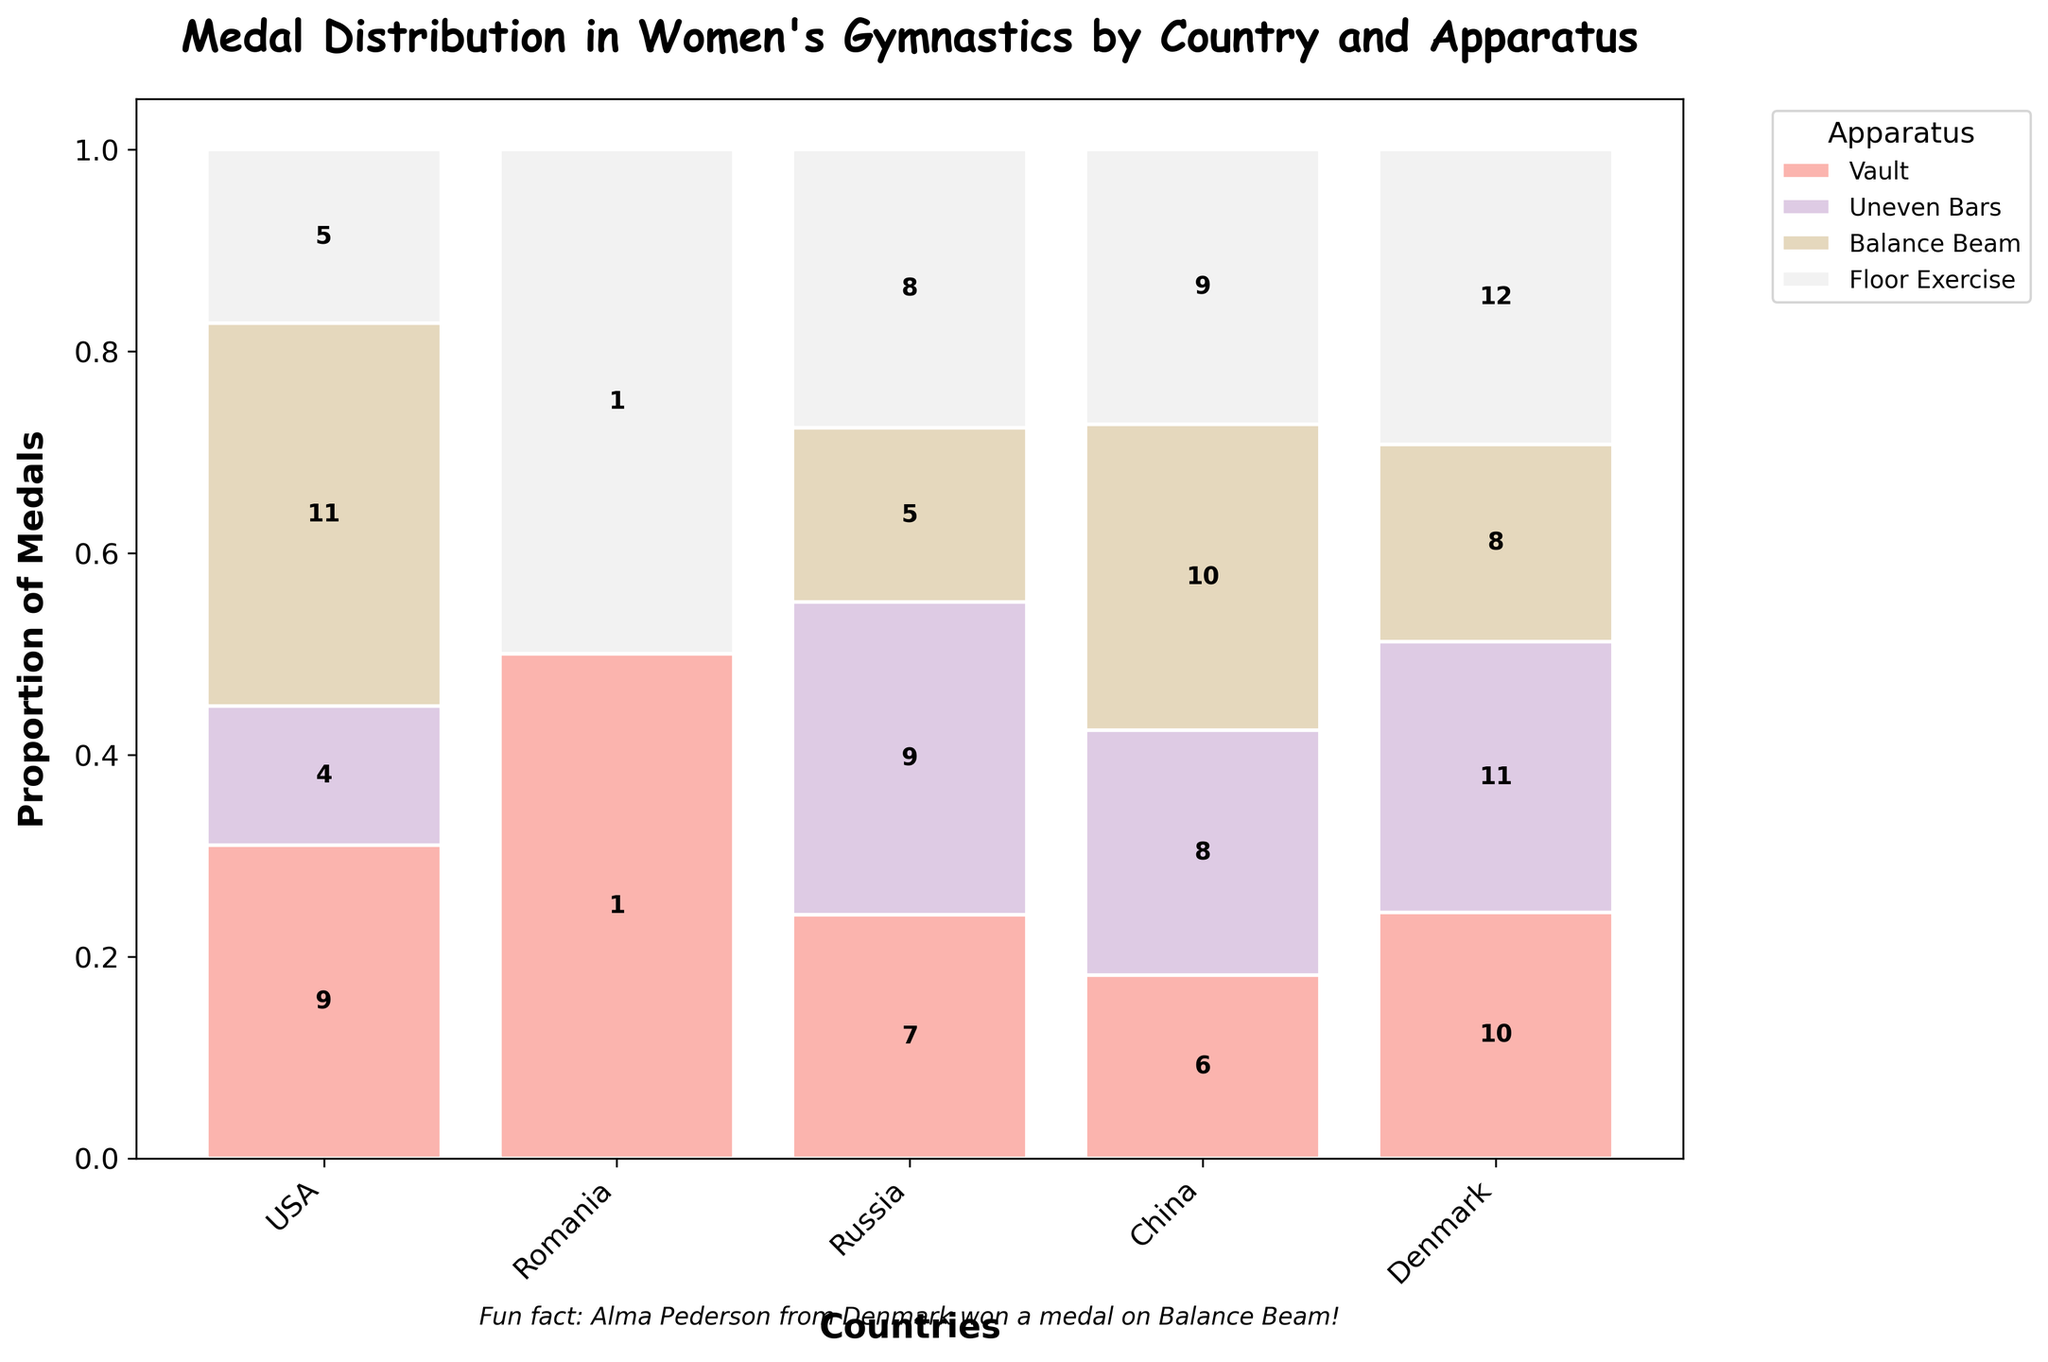What is the title of the plot? The title is displayed prominently above the plot in large, bold font. It reads "Medal Distribution in Women's Gymnastics by Country and Apparatus".
Answer: Medal Distribution in Women's Gymnastics by Country and Apparatus Which country has the highest proportional distribution in Vault? By observing the tallest segment colored for Vault, the USA has the highest segment.
Answer: USA How many medals did China win in the Uneven Bars? Each bar segment includes a label with the number of medals. The segment for China in Uneven Bars shows the number 11.
Answer: 11 What is the relative proportion of medals that Denmark received for Balance Beam? The segment for Denmark in Balance Beam should be compared to the total of Denmark's medals. Since Denmark has only 1 medal each in Vault and Balance Beam (total of 2), the balance beam proportion is 1/2.
Answer: 0.5 Which apparatus did the USA win the most medals in? Looking at the USA bars, the segment with the highest label value should be identified. For the USA, Vault has 12 medals, the highest compared to other apparatus.
Answer: Vault How does the total number of medals won by Russia compare to Romania? Comparing the heights of all segments combined for Russia and Romania, it’s clear that Russia's total taller than Romania’s, thereby indicating more medals.
Answer: Russia won more Which country has the lowest total medal count? Observing the overall height of each country’s bar, Denmark's bar is the shortest, indicating the lowest medal count.
Answer: Denmark What percentage of medals in Floor Exercise were won by Romania? Romania has a total of 29 medals, with 9 in Floor Exercise. The percentage is calculated as (9/29) * 100 = about 31%.
Answer: 31% What proportion of China's medals came from the Balance Beam? China's total medals are 29, with 9 in Balance Beam. The proportion is 9/29.
Answer: 0.31 Among the given apparatus, which one had the most even distribution of medals among the countries? By comparing the height differences across all countries for each apparatus, Uneven Bars shows the most similar height proportions across the countries, indicating the most even distribution.
Answer: Uneven Bars 